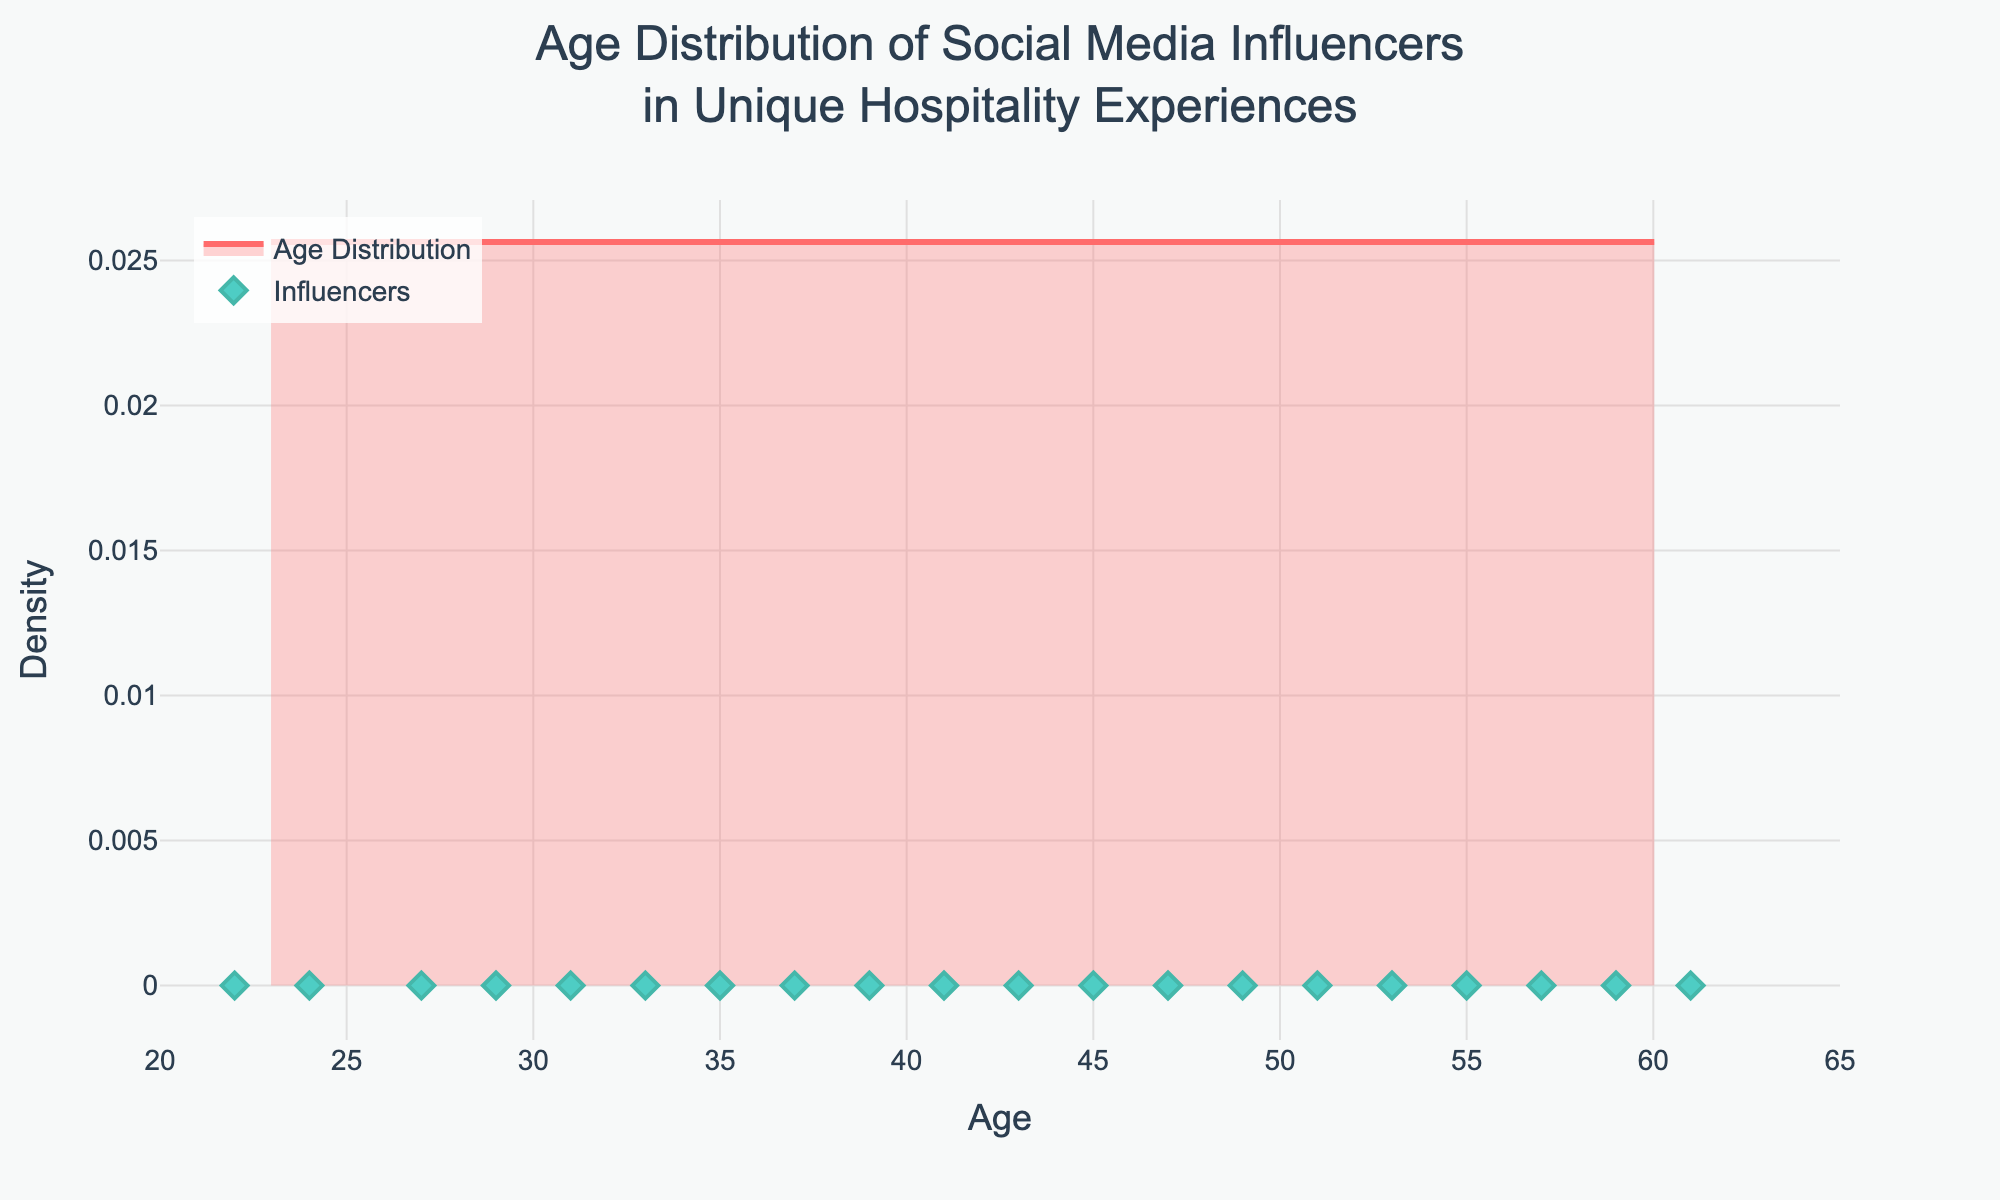What is the title of the figure? The title is located at the top center of the figure and is often the largest text element.
Answer: Age Distribution of Social Media Influencers in Unique Hospitality Experiences What color is used for the density plot line? By observing the line color of the density plot, it is a shade of red.
Answer: Red (#FF6B6B) How many influencers are in the age range of 50 and above? Refer to the scatter plot where each dot represents an influencer. Count the dots within the range from 50 to 65 on the x-axis.
Answer: 7 Which influencer is the youngest and what is their age? Locate the scatter plot dot closest to the lowest x-axis value, hovering over it shows the name and age.
Answer: Emma Chamberlain, 22 What is the peak density of the age distribution? Identify the highest point on the density plot (y-axis) and note its value.
Answer: Approximately 0.025 How does the density of influencers change from age 20 to 30? Observe the density plot line from x=20 to x=30, noting changes in the height (density). It initially increases, peaking around mid-20s, then decreases.
Answer: It increases then decreases Compare the density values at ages 30 and 40. Which is higher? Check the height of the density plot lines at x=30 and x=40. Note which is higher.
Answer: 40 is higher What is the age range with the least number of influencers? Look for the flat or least peak regions in the density plot and check the corresponding x-axis values.
Answer: Mid 50s (55-60) Are there more influencers below 30 or above 50? Count the number of scatter plot points below age 30 and above age 50. Compare the two counts.
Answer: Below 30 How does the density of influencers trending younger compare to trending older? Observe the density plot from younger ages (20-30) versus older ages (50-65) and compare density trends (increasing, peaking, decreasing). Younger trends upwards to peak mid-20s, then declines, whereas older is generally lower and stable.
Answer: Younger trends higher, older is stable 